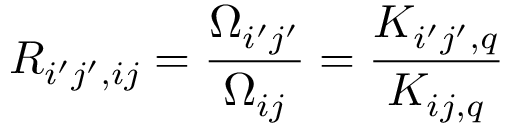<formula> <loc_0><loc_0><loc_500><loc_500>R _ { i ^ { \prime } j ^ { \prime } , i j } = \frac { \Omega _ { i ^ { \prime } j ^ { \prime } } } { \Omega _ { i j } } = \frac { K _ { i ^ { \prime } j ^ { \prime } , q } } { K _ { i j , q } }</formula> 